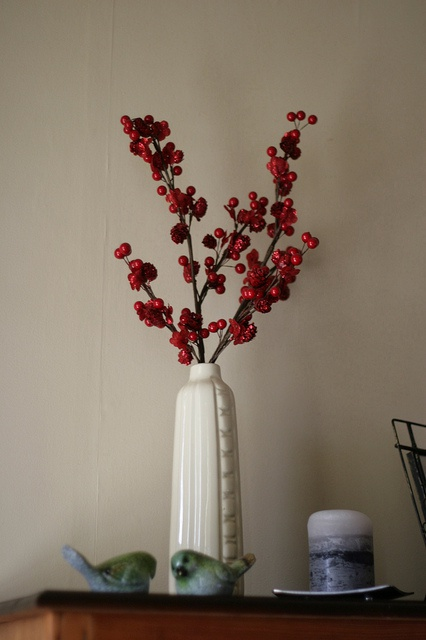Describe the objects in this image and their specific colors. I can see a vase in gray, lightgray, and darkgray tones in this image. 